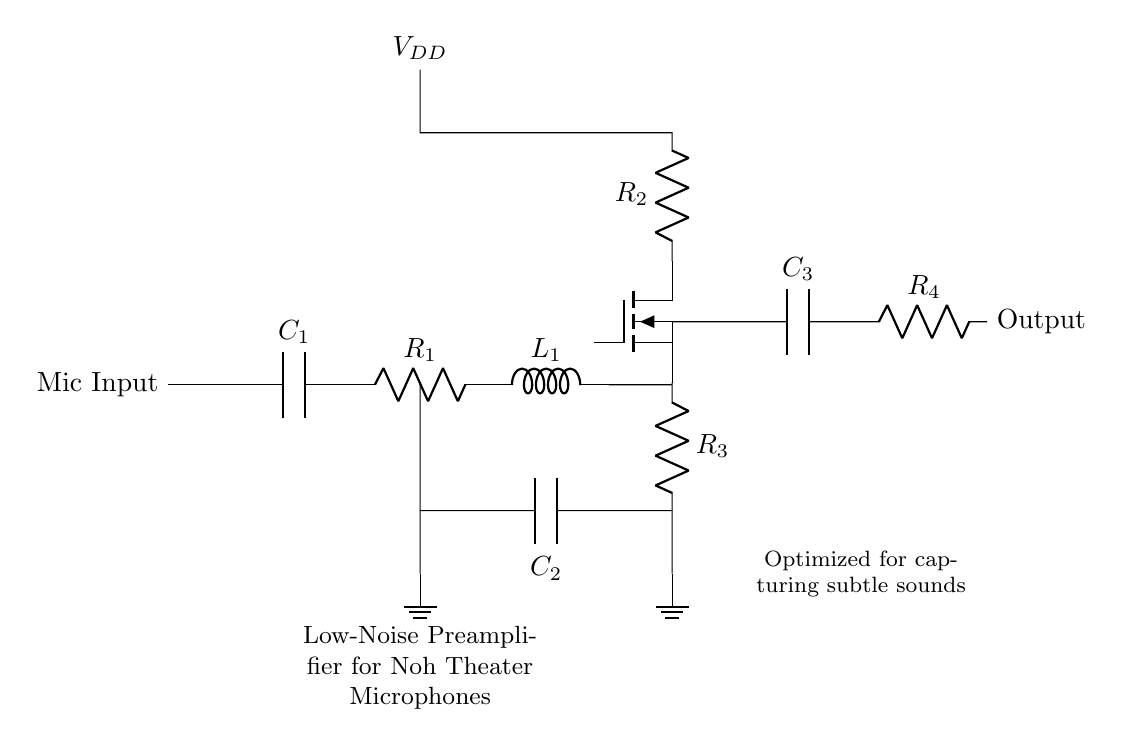What type of transducer is used in this circuit? The circuit includes a microphone input, which implies it uses a transducer to convert sound waves into electrical signals. In this context, it is likely a dynamic or condenser microphone, often associated with high-impedance inputs in audio applications.
Answer: Microphone What is the purpose of the capacitor labeled C1? Capacitor C1 is used for coupling the input signal from the microphone to the amplifier stage while blocking any DC component present in the signal. This allows the AC signal (audio) to pass through while preventing unwanted DC voltage levels from affecting the subsequent circuits.
Answer: Coupling What is the role of R2 in the circuit? R2 acts as a biasing resistor for the JFET, ensuring that the transistor operates in the correct region for amplification. It helps set the operating point and stability of the amplifier circuit, which is crucial for maintaining low noise levels during operation.
Answer: Biasing How many capacitors are present in the circuit? The circuit diagram shows three distinct capacitors: C1, C2, and C3. Each capacitor serves specific functions related to coupling, feedback, and output smoothing. Counting them gives a total of three capacitors.
Answer: Three What type of amplifier is represented in this diagram? The inclusion of a JFET (Junction Field Effect Transistor) in the circuit identifies it as a JFET amplifier. Its design emphasizes low-noise characteristics, making it suitable for applications like Noh theater where capturing subtle sounds is essential.
Answer: JFET What is the function of the feedback capacitor C2? Capacitor C2 in this circuit is part of a feedback network, which helps stabilize the gain and reduce distortion in the amplifier output. By providing feedback, it ensures better linearity and improved sonic performance, critical for accurately capturing subtle audio signals.
Answer: Stabilize gain 